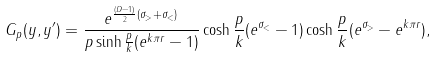Convert formula to latex. <formula><loc_0><loc_0><loc_500><loc_500>G _ { p } ( y , y ^ { \prime } ) = \frac { e ^ { \frac { ( D - 1 ) } { 2 } ( \sigma _ { > } + \sigma _ { < } ) } } { p \sinh \frac { p } { k } ( e ^ { k \pi r } - 1 ) } \cosh \frac { p } { k } ( e ^ { \sigma _ { < } } - 1 ) \cosh \frac { p } { k } ( e ^ { \sigma _ { > } } - e ^ { k \pi r } ) ,</formula> 